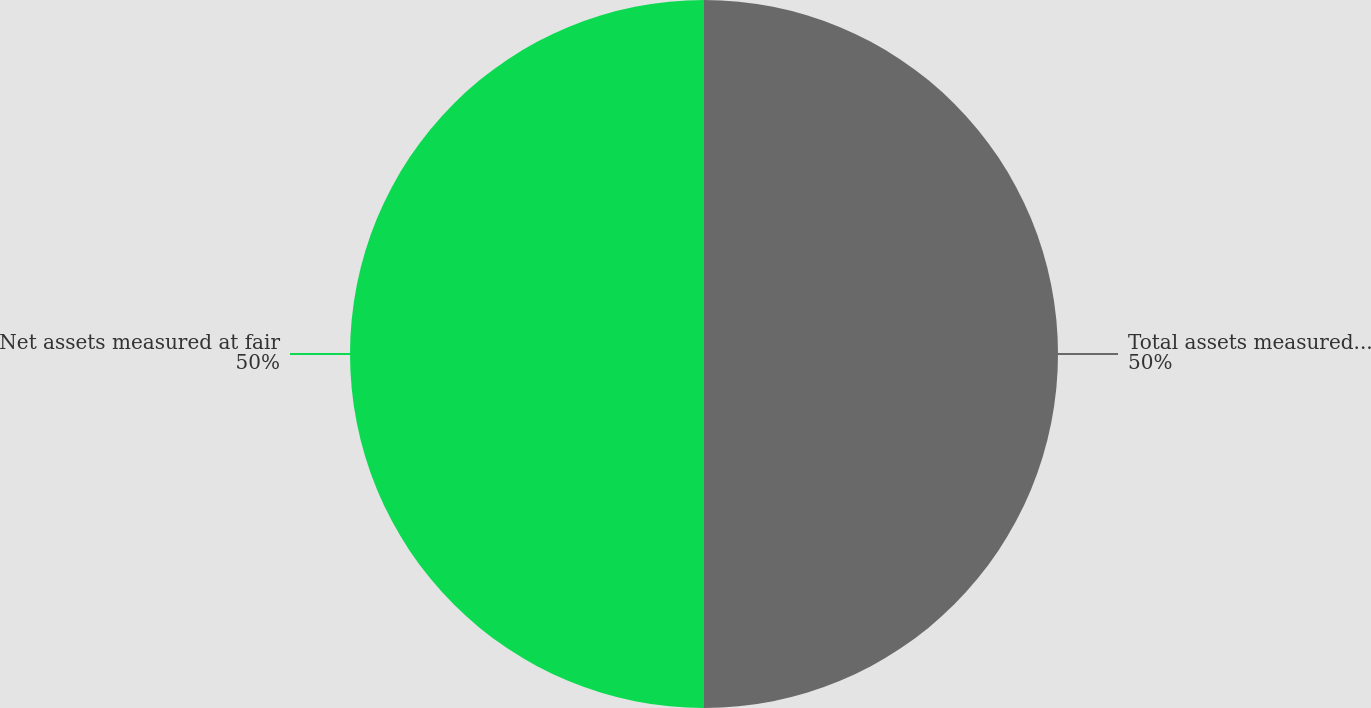Convert chart. <chart><loc_0><loc_0><loc_500><loc_500><pie_chart><fcel>Total assets measured at fair<fcel>Net assets measured at fair<nl><fcel>50.0%<fcel>50.0%<nl></chart> 